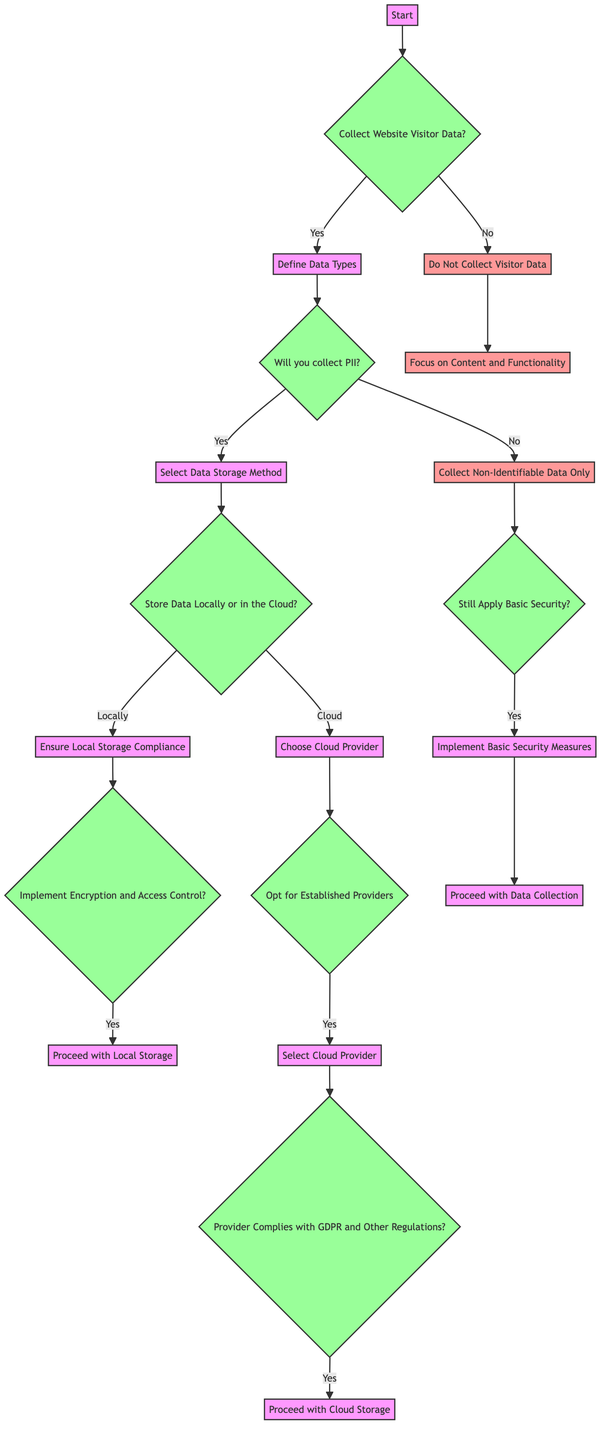What is the first decision point in the diagram? The first decision point in the diagram is "Collect Website Visitor Data?". It is the initial condition that leads to further decisions based on the response.
Answer: Collect Website Visitor Data? How many main branches come out of the first decision node? The first decision node has two main branches: "Yes" and "No". This leads to different pathways depending on whether website visitor data is collected.
Answer: Two What happens if you choose to "Collect Non-Identifiable Data Only"? If "Collect Non-Identifiable Data Only" is chosen, the next decision is whether to still apply basic security, leading to an option to implement basic security measures if the answer is "Yes".
Answer: Implement Basic Security Measures How many conditions lead to proceeding with cloud storage? There are two conditions that need to be satisfied in order to proceed with cloud storage: choosing established providers and ensuring the provider complies with GDPR and other regulations.
Answer: Two What is required to proceed with local storage? To proceed with local storage, it is required to implement encryption and access control. This is a necessary step for compliance and data security.
Answer: Implement Encryption and Access Control What is the end node if website visitor data is not collected? If website visitor data is not collected, the end node is "Focus on Content and Functionality", indicating a shift in priorities away from data collection.
Answer: Focus on Content and Functionality If "Opt for Established Providers" is answered with "Yes", which condition follows? After answering "Yes" to "Opt for Established Providers", the next condition is to check if the chosen provider complies with GDPR and other regulations before proceeding with cloud storage.
Answer: Provider Complies with GDPR and Other Regulations? What action is taken if "Implement Encryption and Access Control?" is answered with "Yes"? If "Implement Encryption and Access Control?" is answered with "Yes", the action taken is "Proceed with Local Storage", indicating that the necessary security measures are in place.
Answer: Proceed with Local Storage How is the flow affected by selecting "Store Data Locally"? Choosing to "Store Data Locally" leads to the requirement of ensuring local storage compliance and implementing encryption and access control before proceeding, influencing the security measures required for this option.
Answer: Ensure Local Storage Compliance 